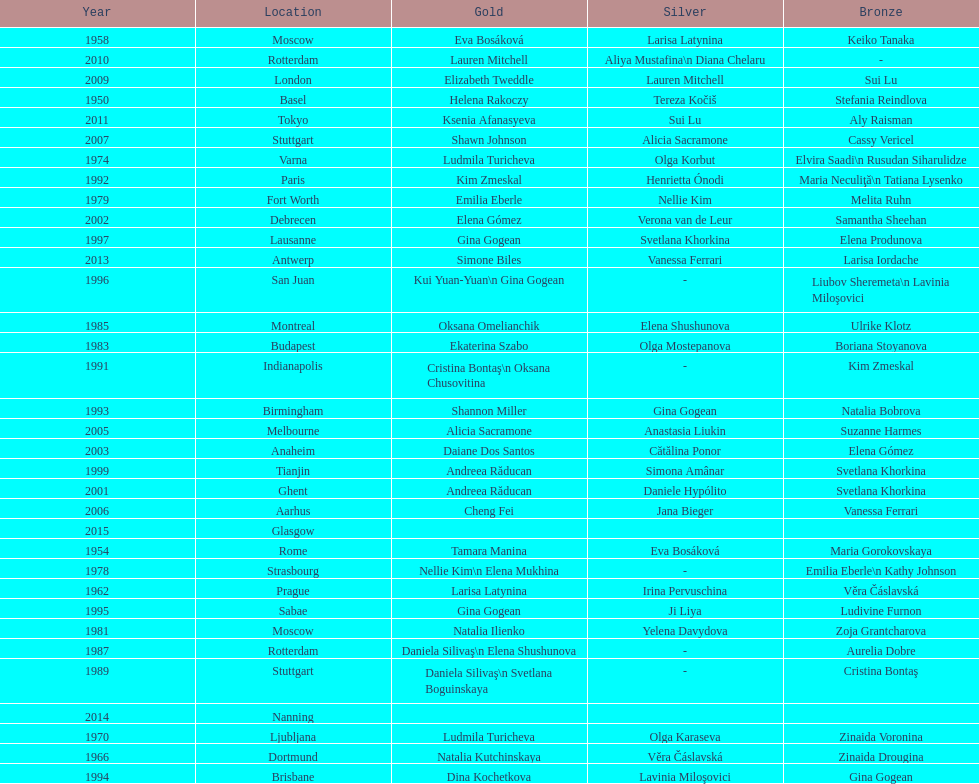How many times was the world artistic gymnastics championships held in the united states? 3. Could you parse the entire table as a dict? {'header': ['Year', 'Location', 'Gold', 'Silver', 'Bronze'], 'rows': [['1958', 'Moscow', 'Eva Bosáková', 'Larisa Latynina', 'Keiko Tanaka'], ['2010', 'Rotterdam', 'Lauren Mitchell', 'Aliya Mustafina\\n Diana Chelaru', '-'], ['2009', 'London', 'Elizabeth Tweddle', 'Lauren Mitchell', 'Sui Lu'], ['1950', 'Basel', 'Helena Rakoczy', 'Tereza Kočiš', 'Stefania Reindlova'], ['2011', 'Tokyo', 'Ksenia Afanasyeva', 'Sui Lu', 'Aly Raisman'], ['2007', 'Stuttgart', 'Shawn Johnson', 'Alicia Sacramone', 'Cassy Vericel'], ['1974', 'Varna', 'Ludmila Turicheva', 'Olga Korbut', 'Elvira Saadi\\n Rusudan Siharulidze'], ['1992', 'Paris', 'Kim Zmeskal', 'Henrietta Ónodi', 'Maria Neculiţă\\n Tatiana Lysenko'], ['1979', 'Fort Worth', 'Emilia Eberle', 'Nellie Kim', 'Melita Ruhn'], ['2002', 'Debrecen', 'Elena Gómez', 'Verona van de Leur', 'Samantha Sheehan'], ['1997', 'Lausanne', 'Gina Gogean', 'Svetlana Khorkina', 'Elena Produnova'], ['2013', 'Antwerp', 'Simone Biles', 'Vanessa Ferrari', 'Larisa Iordache'], ['1996', 'San Juan', 'Kui Yuan-Yuan\\n Gina Gogean', '-', 'Liubov Sheremeta\\n Lavinia Miloşovici'], ['1985', 'Montreal', 'Oksana Omelianchik', 'Elena Shushunova', 'Ulrike Klotz'], ['1983', 'Budapest', 'Ekaterina Szabo', 'Olga Mostepanova', 'Boriana Stoyanova'], ['1991', 'Indianapolis', 'Cristina Bontaş\\n Oksana Chusovitina', '-', 'Kim Zmeskal'], ['1993', 'Birmingham', 'Shannon Miller', 'Gina Gogean', 'Natalia Bobrova'], ['2005', 'Melbourne', 'Alicia Sacramone', 'Anastasia Liukin', 'Suzanne Harmes'], ['2003', 'Anaheim', 'Daiane Dos Santos', 'Cătălina Ponor', 'Elena Gómez'], ['1999', 'Tianjin', 'Andreea Răducan', 'Simona Amânar', 'Svetlana Khorkina'], ['2001', 'Ghent', 'Andreea Răducan', 'Daniele Hypólito', 'Svetlana Khorkina'], ['2006', 'Aarhus', 'Cheng Fei', 'Jana Bieger', 'Vanessa Ferrari'], ['2015', 'Glasgow', '', '', ''], ['1954', 'Rome', 'Tamara Manina', 'Eva Bosáková', 'Maria Gorokovskaya'], ['1978', 'Strasbourg', 'Nellie Kim\\n Elena Mukhina', '-', 'Emilia Eberle\\n Kathy Johnson'], ['1962', 'Prague', 'Larisa Latynina', 'Irina Pervuschina', 'Věra Čáslavská'], ['1995', 'Sabae', 'Gina Gogean', 'Ji Liya', 'Ludivine Furnon'], ['1981', 'Moscow', 'Natalia Ilienko', 'Yelena Davydova', 'Zoja Grantcharova'], ['1987', 'Rotterdam', 'Daniela Silivaş\\n Elena Shushunova', '-', 'Aurelia Dobre'], ['1989', 'Stuttgart', 'Daniela Silivaş\\n Svetlana Boguinskaya', '-', 'Cristina Bontaş'], ['2014', 'Nanning', '', '', ''], ['1970', 'Ljubljana', 'Ludmila Turicheva', 'Olga Karaseva', 'Zinaida Voronina'], ['1966', 'Dortmund', 'Natalia Kutchinskaya', 'Věra Čáslavská', 'Zinaida Drougina'], ['1994', 'Brisbane', 'Dina Kochetkova', 'Lavinia Miloşovici', 'Gina Gogean']]} 